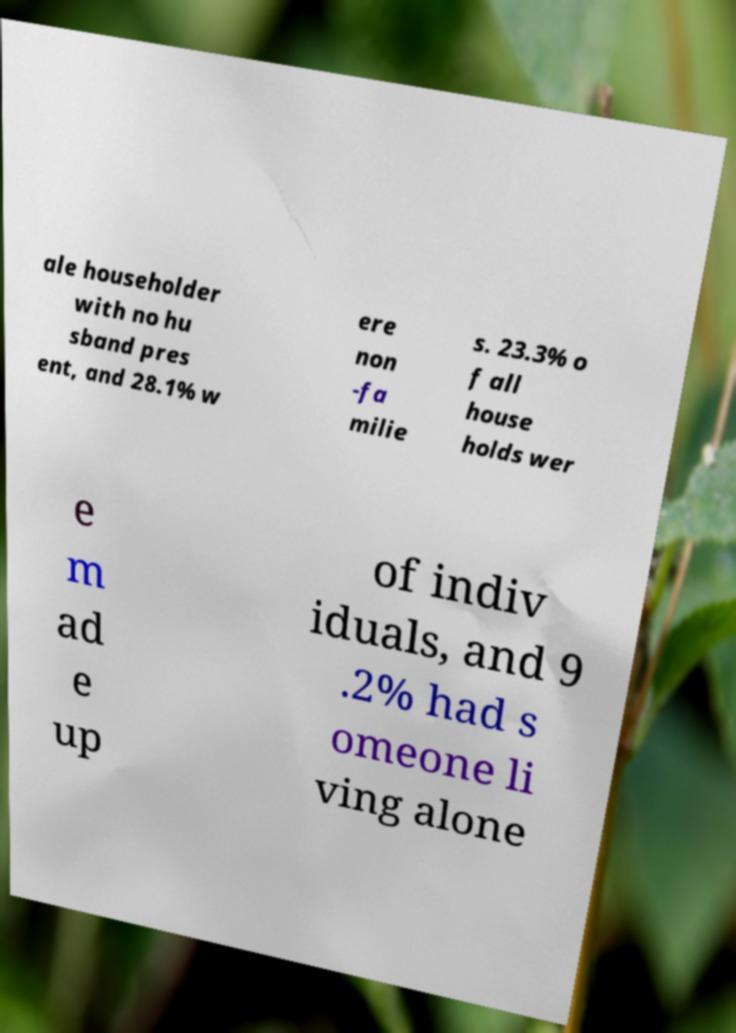For documentation purposes, I need the text within this image transcribed. Could you provide that? ale householder with no hu sband pres ent, and 28.1% w ere non -fa milie s. 23.3% o f all house holds wer e m ad e up of indiv iduals, and 9 .2% had s omeone li ving alone 